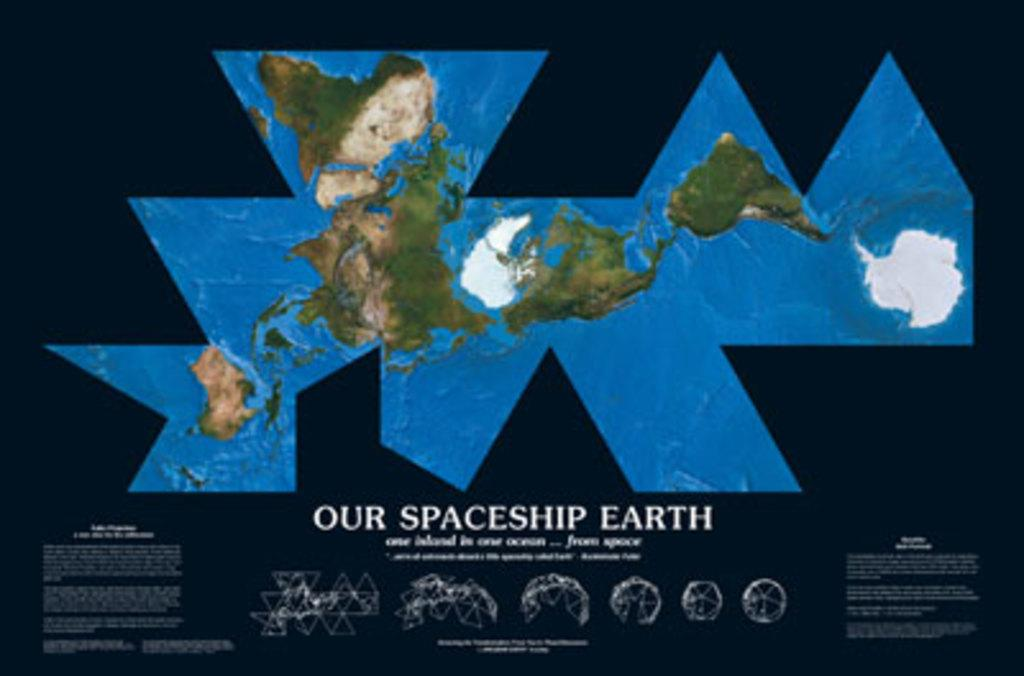<image>
Render a clear and concise summary of the photo. A flat map of the world with Our Spaceship Earth at the bottom. 